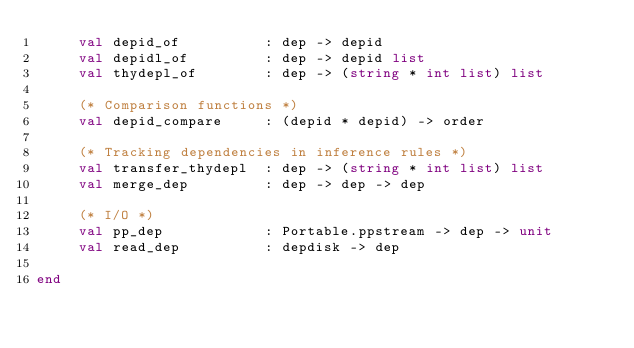<code> <loc_0><loc_0><loc_500><loc_500><_SML_>     val depid_of          : dep -> depid
     val depidl_of         : dep -> depid list
     val thydepl_of        : dep -> (string * int list) list

     (* Comparison functions *)
     val depid_compare     : (depid * depid) -> order

     (* Tracking dependencies in inference rules *)
     val transfer_thydepl  : dep -> (string * int list) list
     val merge_dep         : dep -> dep -> dep

     (* I/O *)
     val pp_dep            : Portable.ppstream -> dep -> unit
     val read_dep          : depdisk -> dep

end
</code> 